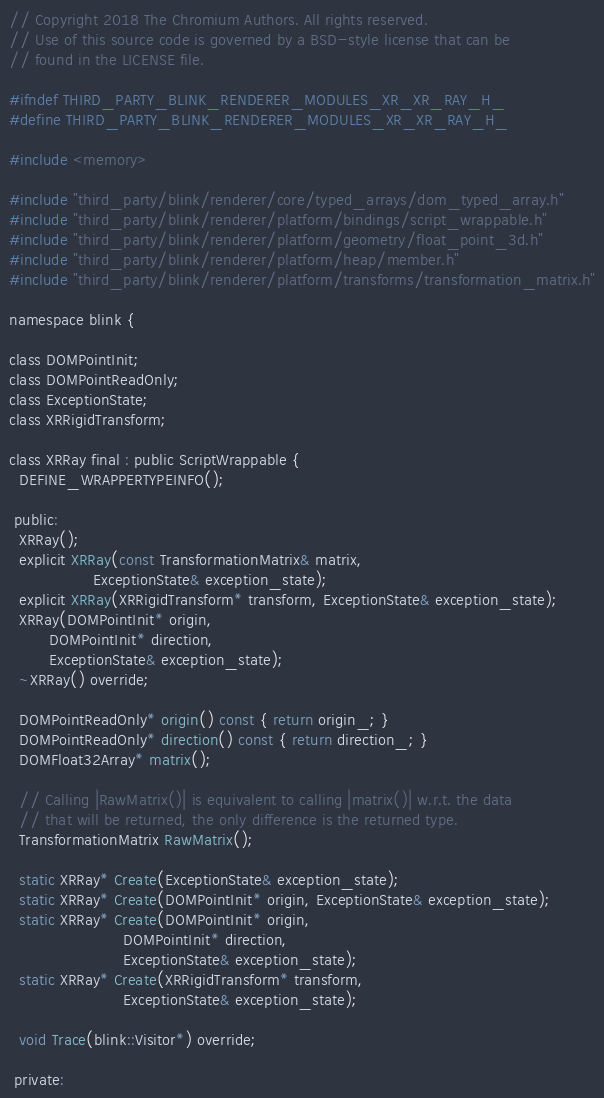Convert code to text. <code><loc_0><loc_0><loc_500><loc_500><_C_>// Copyright 2018 The Chromium Authors. All rights reserved.
// Use of this source code is governed by a BSD-style license that can be
// found in the LICENSE file.

#ifndef THIRD_PARTY_BLINK_RENDERER_MODULES_XR_XR_RAY_H_
#define THIRD_PARTY_BLINK_RENDERER_MODULES_XR_XR_RAY_H_

#include <memory>

#include "third_party/blink/renderer/core/typed_arrays/dom_typed_array.h"
#include "third_party/blink/renderer/platform/bindings/script_wrappable.h"
#include "third_party/blink/renderer/platform/geometry/float_point_3d.h"
#include "third_party/blink/renderer/platform/heap/member.h"
#include "third_party/blink/renderer/platform/transforms/transformation_matrix.h"

namespace blink {

class DOMPointInit;
class DOMPointReadOnly;
class ExceptionState;
class XRRigidTransform;

class XRRay final : public ScriptWrappable {
  DEFINE_WRAPPERTYPEINFO();

 public:
  XRRay();
  explicit XRRay(const TransformationMatrix& matrix,
                 ExceptionState& exception_state);
  explicit XRRay(XRRigidTransform* transform, ExceptionState& exception_state);
  XRRay(DOMPointInit* origin,
        DOMPointInit* direction,
        ExceptionState& exception_state);
  ~XRRay() override;

  DOMPointReadOnly* origin() const { return origin_; }
  DOMPointReadOnly* direction() const { return direction_; }
  DOMFloat32Array* matrix();

  // Calling |RawMatrix()| is equivalent to calling |matrix()| w.r.t. the data
  // that will be returned, the only difference is the returned type.
  TransformationMatrix RawMatrix();

  static XRRay* Create(ExceptionState& exception_state);
  static XRRay* Create(DOMPointInit* origin, ExceptionState& exception_state);
  static XRRay* Create(DOMPointInit* origin,
                       DOMPointInit* direction,
                       ExceptionState& exception_state);
  static XRRay* Create(XRRigidTransform* transform,
                       ExceptionState& exception_state);

  void Trace(blink::Visitor*) override;

 private:</code> 